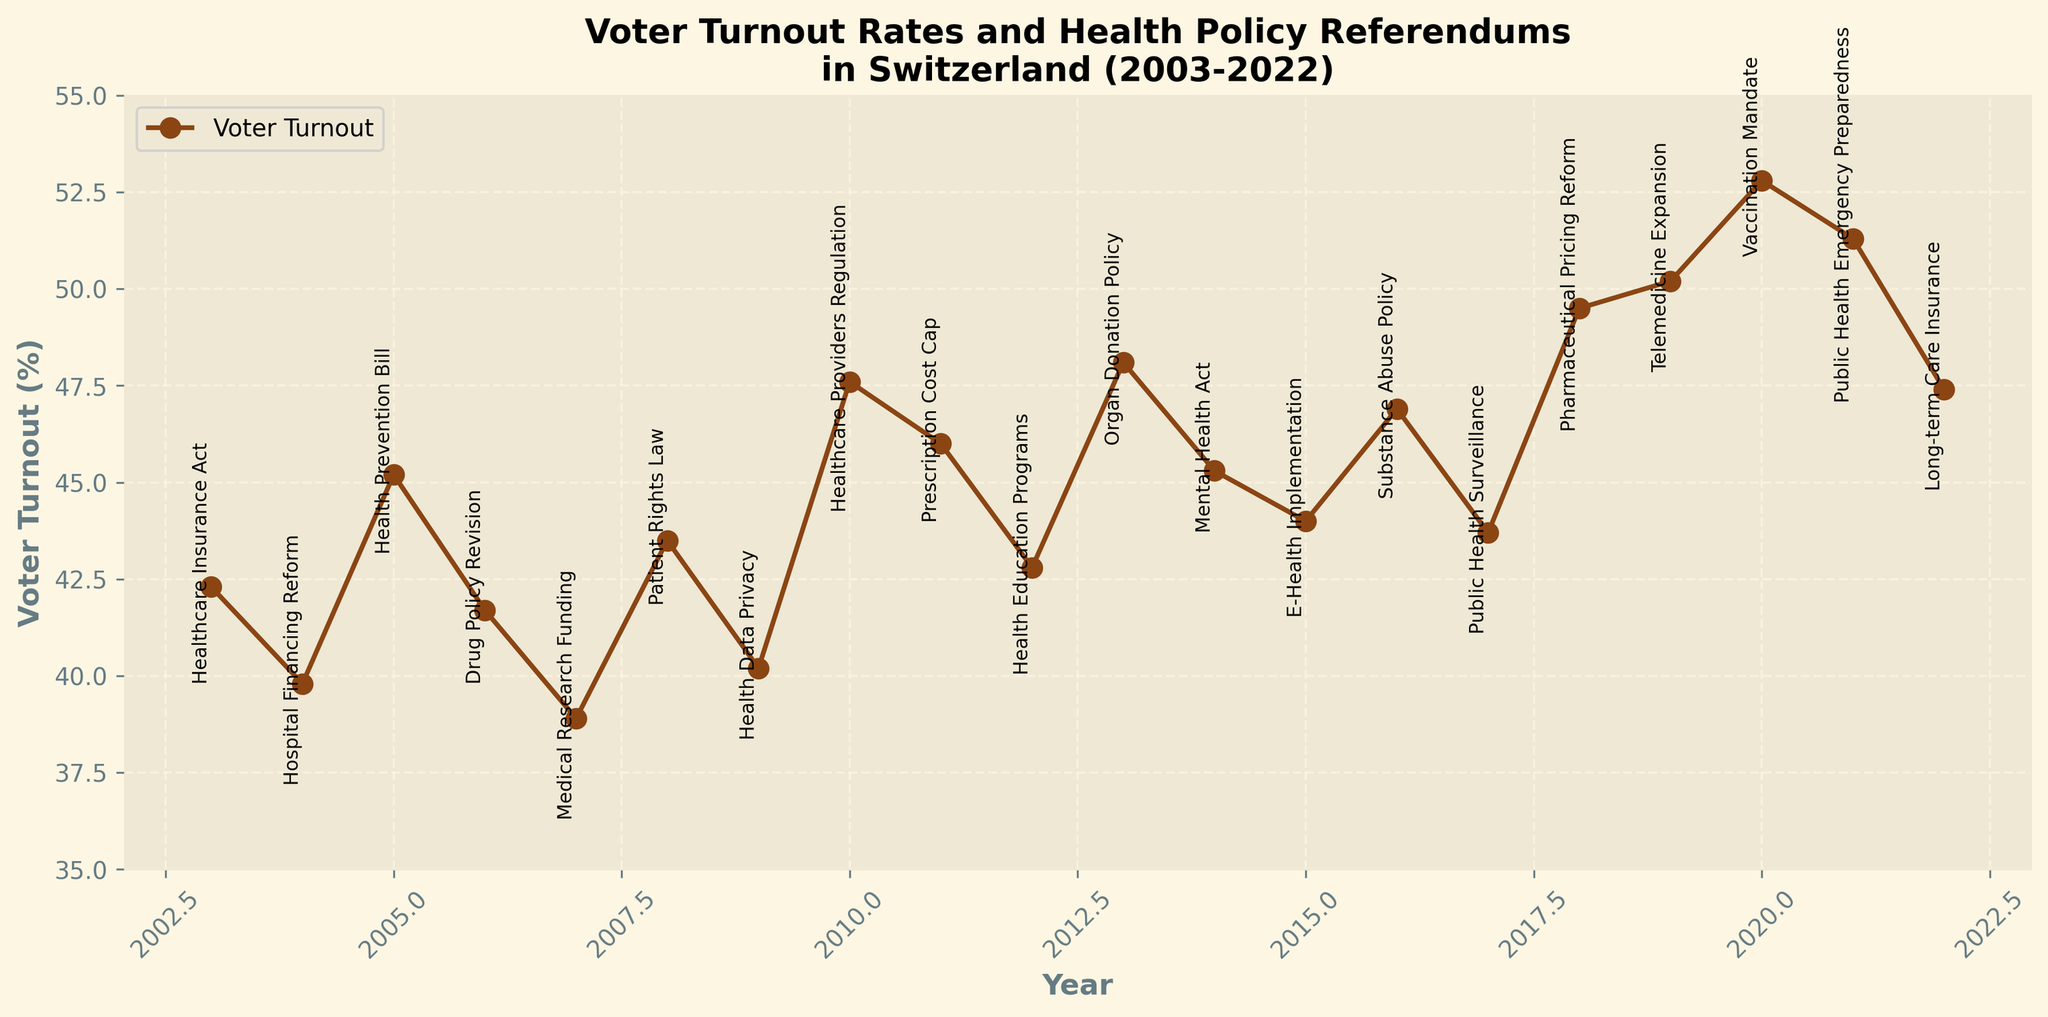how many referendums are listed on the figure? The figure plots data points for each year from 2003 to 2022, with each data point corresponding to a health policy referendum. To find the total number of referendums, count the data points on the plot.
Answer: 20 what is the title of the figure? The title is typically located at the top of the figure in a bold font. Read the text directly from this location.
Answer: Voter Turnout Rates and Health Policy Referendums in Switzerland (2003-2022) what was the highest voter turnout rate and in which year did it occur? Look for the peak point along the 'Voter Turnout (%)' axis. The year corresponding to this peak will be labeled.
Answer: The highest turnout rate was 52.8% in 2020 what was the voter turnout rate in 2007? Locate the data point for the year 2007 on the x-axis and read the corresponding voter turnout rate on the y-axis.
Answer: 38.9% which health policy referendum coincided with the highest voter turnout? Identify the data point with the highest voter turnout rate on the plot. Look at the label associated with this point.
Answer: Vaccination Mandate what is the trend in voter turnout rates from 2015 to 2020? Analyze the data points along the timeline from 2015 to 2020. Note the progression of the voter turnout values.
Answer: Increasing trend what is the difference in voter turnout rates between 2003 and 2022? Subtract the voter turnout rate in 2003 from that in 2022. First identify these values from the y-axis.
Answer: 47.4% - 42.3% = 5.1% compare the voter turnout rates for the years with the 'Healthcare Providers Regulation' and 'Telemedicine Expansion' referendums. Which year had a higher turnout? Identify the years for these referendums (2010 and 2019). Compare their voter turnout rates by locating the data points on the y-axis.
Answer: Telemedicine Expansion had a higher turnout in 2019 with 50.2% compared to 47.6% in 2010 what is the average voter turnout rate for the years 2018 to 2020 inclusive? Sum the voter turnout rates for 2018, 2019, and 2020, then divide by the number of years (3). Identify the values from the plot and perform the calculation.
Answer: (49.5 + 50.2 + 52.8) / 3 = 50.83% what health policy referendum occurred in 2014, and what was the voter turnout rate for that year? Locate the data point for the year 2014 on the plot, and read the referendum label and corresponding voter turnout rate.
Answer: Mental Health Act, 45.3% 